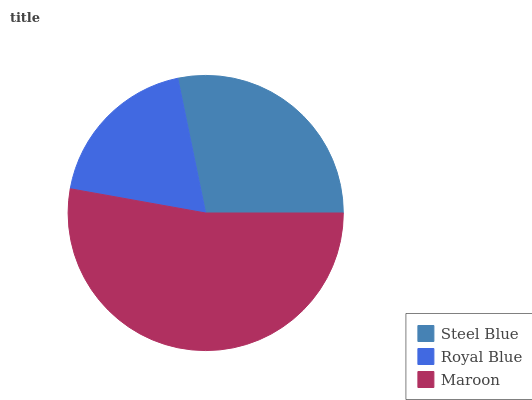Is Royal Blue the minimum?
Answer yes or no. Yes. Is Maroon the maximum?
Answer yes or no. Yes. Is Maroon the minimum?
Answer yes or no. No. Is Royal Blue the maximum?
Answer yes or no. No. Is Maroon greater than Royal Blue?
Answer yes or no. Yes. Is Royal Blue less than Maroon?
Answer yes or no. Yes. Is Royal Blue greater than Maroon?
Answer yes or no. No. Is Maroon less than Royal Blue?
Answer yes or no. No. Is Steel Blue the high median?
Answer yes or no. Yes. Is Steel Blue the low median?
Answer yes or no. Yes. Is Royal Blue the high median?
Answer yes or no. No. Is Maroon the low median?
Answer yes or no. No. 